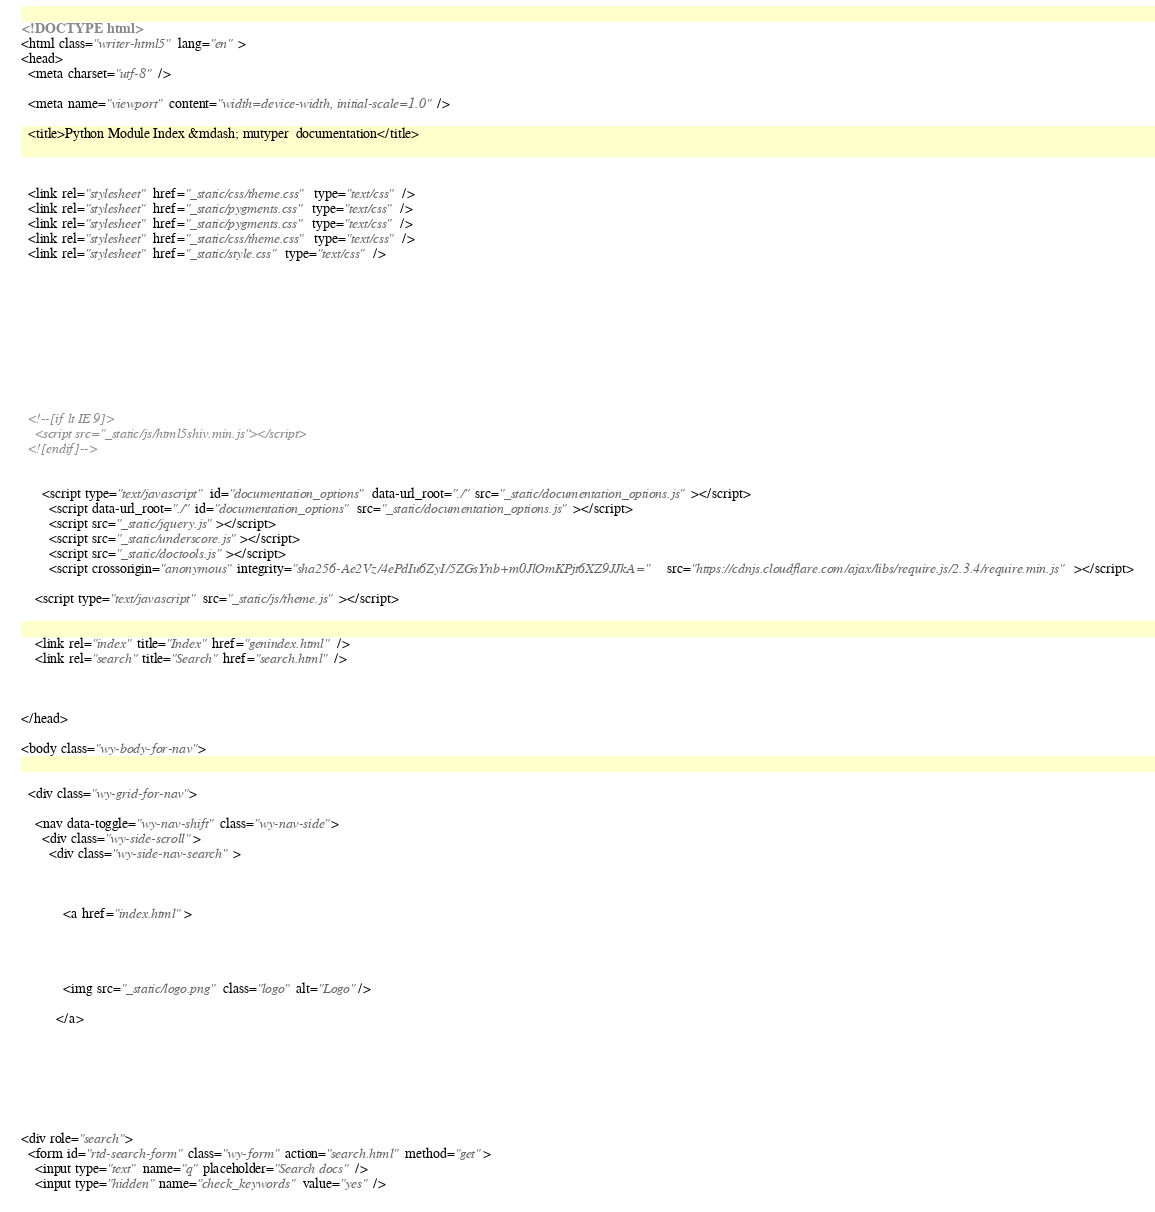Convert code to text. <code><loc_0><loc_0><loc_500><loc_500><_HTML_>

<!DOCTYPE html>
<html class="writer-html5" lang="en" >
<head>
  <meta charset="utf-8" />
  
  <meta name="viewport" content="width=device-width, initial-scale=1.0" />
  
  <title>Python Module Index &mdash; mutyper  documentation</title>
  

  
  <link rel="stylesheet" href="_static/css/theme.css" type="text/css" />
  <link rel="stylesheet" href="_static/pygments.css" type="text/css" />
  <link rel="stylesheet" href="_static/pygments.css" type="text/css" />
  <link rel="stylesheet" href="_static/css/theme.css" type="text/css" />
  <link rel="stylesheet" href="_static/style.css" type="text/css" />

  
  

  
  

  

  
  <!--[if lt IE 9]>
    <script src="_static/js/html5shiv.min.js"></script>
  <![endif]-->
  
    
      <script type="text/javascript" id="documentation_options" data-url_root="./" src="_static/documentation_options.js"></script>
        <script data-url_root="./" id="documentation_options" src="_static/documentation_options.js"></script>
        <script src="_static/jquery.js"></script>
        <script src="_static/underscore.js"></script>
        <script src="_static/doctools.js"></script>
        <script crossorigin="anonymous" integrity="sha256-Ae2Vz/4ePdIu6ZyI/5ZGsYnb+m0JlOmKPjt6XZ9JJkA=" src="https://cdnjs.cloudflare.com/ajax/libs/require.js/2.3.4/require.min.js"></script>
    
    <script type="text/javascript" src="_static/js/theme.js"></script>

    
    <link rel="index" title="Index" href="genindex.html" />
    <link rel="search" title="Search" href="search.html" />
 


</head>

<body class="wy-body-for-nav">

   
  <div class="wy-grid-for-nav">
    
    <nav data-toggle="wy-nav-shift" class="wy-nav-side">
      <div class="wy-side-scroll">
        <div class="wy-side-nav-search" >
          

          
            <a href="index.html">
          

          
            
            <img src="_static/logo.png" class="logo" alt="Logo"/>
          
          </a>

          
            
            
          

          
<div role="search">
  <form id="rtd-search-form" class="wy-form" action="search.html" method="get">
    <input type="text" name="q" placeholder="Search docs" />
    <input type="hidden" name="check_keywords" value="yes" /></code> 